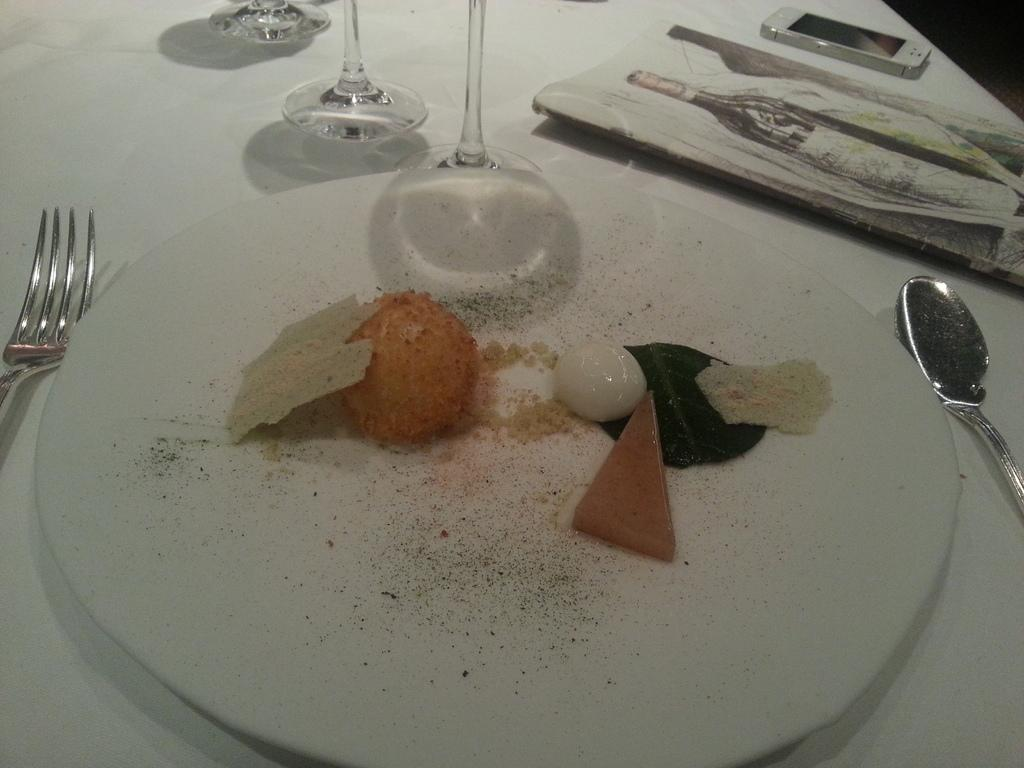What type of utensils can be seen in the image? There is a fork and a spoon in the image. What other items are present on the table in the image? There are glasses, a menu card, a mobile, and a plate with food in the image. What might be used to read about the available dishes in the image? There is a menu card in the image for reading about the available dishes. How is the food served in the image? The food is served in a plate in the image. What type of board is used to measure the growth of the straw in the image? There is no board or straw present in the image. 